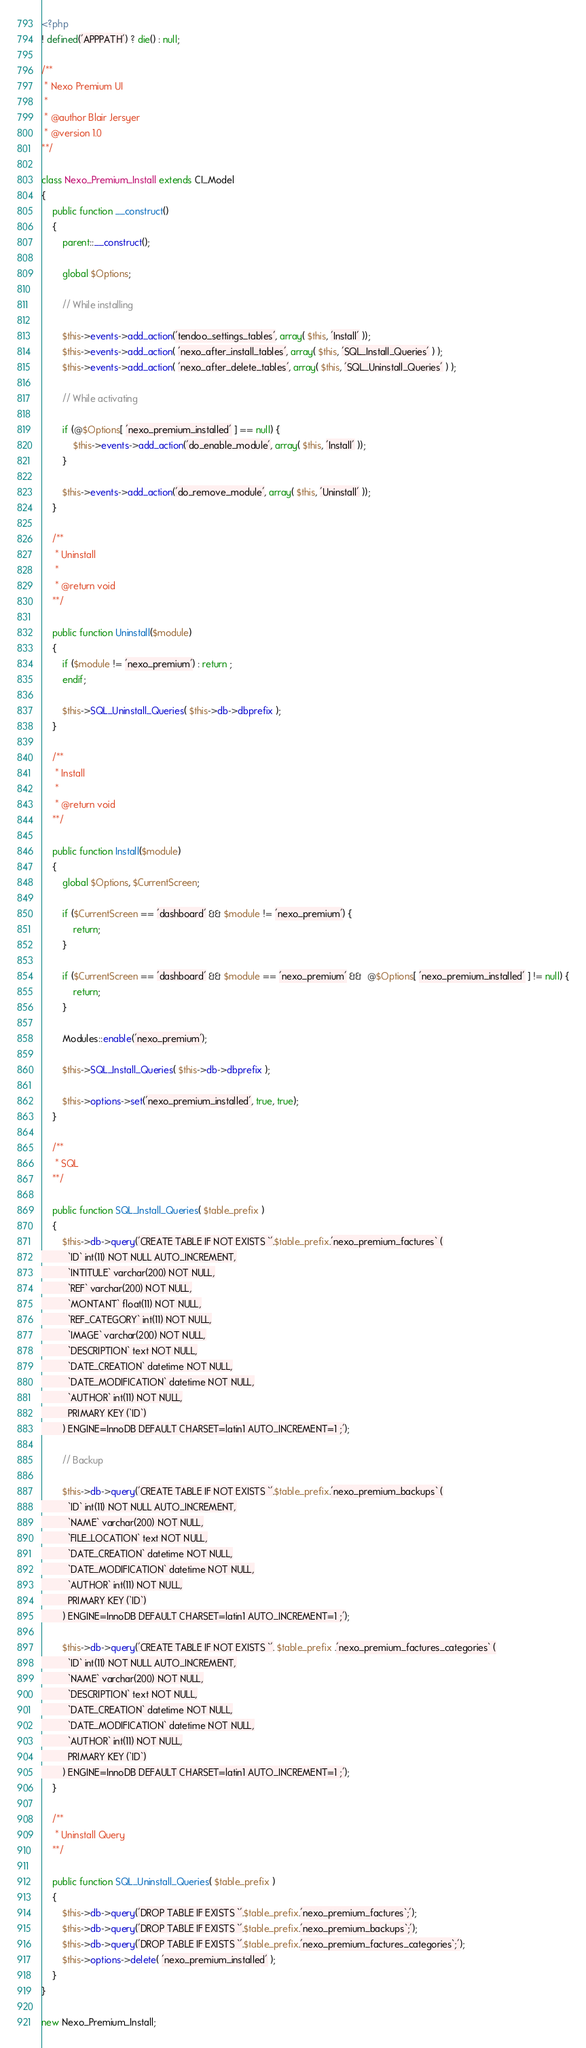Convert code to text. <code><loc_0><loc_0><loc_500><loc_500><_PHP_><?php
! defined('APPPATH') ? die() : null;

/**
 * Nexo Premium UI
 *
 * @author Blair Jersyer
 * @version 1.0
**/

class Nexo_Premium_Install extends CI_Model
{
    public function __construct()
    {
        parent::__construct();

        global $Options;

        // While installing

        $this->events->add_action('tendoo_settings_tables', array( $this, 'Install' ));
		$this->events->add_action( 'nexo_after_install_tables', array( $this, 'SQL_Install_Queries' ) );
		$this->events->add_action( 'nexo_after_delete_tables', array( $this, 'SQL_Uninstall_Queries' ) );

        // While activating

        if (@$Options[ 'nexo_premium_installed' ] == null) {
            $this->events->add_action('do_enable_module', array( $this, 'Install' ));
        }

        $this->events->add_action('do_remove_module', array( $this, 'Uninstall' ));
    }

    /**
     * Uninstall
     *
     * @return void
    **/

    public function Uninstall($module)
    {
        if ($module != 'nexo_premium') : return ;
        endif;

		$this->SQL_Uninstall_Queries( $this->db->dbprefix );
    }

    /**
     * Install
     *
     * @return void
    **/

    public function Install($module)
    {
        global $Options, $CurrentScreen;

        if ($CurrentScreen == 'dashboard' && $module != 'nexo_premium') {
            return;
        }

        if ($CurrentScreen == 'dashboard' && $module == 'nexo_premium' &&  @$Options[ 'nexo_premium_installed' ] != null) {
            return;
        }

        Modules::enable('nexo_premium');

        $this->SQL_Install_Queries( $this->db->dbprefix );

        $this->options->set('nexo_premium_installed', true, true);
    }

	/**
	 * SQL
	**/

	public function SQL_Install_Queries( $table_prefix )
	{
		$this->db->query('CREATE TABLE IF NOT EXISTS `'.$table_prefix.'nexo_premium_factures` (
		  `ID` int(11) NOT NULL AUTO_INCREMENT,
		  `INTITULE` varchar(200) NOT NULL,
		  `REF` varchar(200) NOT NULL,
		  `MONTANT` float(11) NOT NULL,
          `REF_CATEGORY` int(11) NOT NULL,
		  `IMAGE` varchar(200) NOT NULL,
		  `DESCRIPTION` text NOT NULL,
		  `DATE_CREATION` datetime NOT NULL,
		  `DATE_MODIFICATION` datetime NOT NULL,
		  `AUTHOR` int(11) NOT NULL,
		  PRIMARY KEY (`ID`)
		) ENGINE=InnoDB DEFAULT CHARSET=latin1 AUTO_INCREMENT=1 ;');

        // Backup

        $this->db->query('CREATE TABLE IF NOT EXISTS `'.$table_prefix.'nexo_premium_backups` (
		  `ID` int(11) NOT NULL AUTO_INCREMENT,
		  `NAME` varchar(200) NOT NULL,
		  `FILE_LOCATION` text NOT NULL,
		  `DATE_CREATION` datetime NOT NULL,
		  `DATE_MODIFICATION` datetime NOT NULL,
		  `AUTHOR` int(11) NOT NULL,
		  PRIMARY KEY (`ID`)
		) ENGINE=InnoDB DEFAULT CHARSET=latin1 AUTO_INCREMENT=1 ;');

        $this->db->query('CREATE TABLE IF NOT EXISTS `'. $table_prefix .'nexo_premium_factures_categories` (
          `ID` int(11) NOT NULL AUTO_INCREMENT,
          `NAME` varchar(200) NOT NULL,
          `DESCRIPTION` text NOT NULL,
          `DATE_CREATION` datetime NOT NULL,
          `DATE_MODIFICATION` datetime NOT NULL,
          `AUTHOR` int(11) NOT NULL,
          PRIMARY KEY (`ID`)
        ) ENGINE=InnoDB DEFAULT CHARSET=latin1 AUTO_INCREMENT=1 ;');
	}

	/**
	 * Uninstall Query
	**/

	public function SQL_Uninstall_Queries( $table_prefix )
	{
		$this->db->query('DROP TABLE IF EXISTS `'.$table_prefix.'nexo_premium_factures`;');
		$this->db->query('DROP TABLE IF EXISTS `'.$table_prefix.'nexo_premium_backups`;');
        $this->db->query('DROP TABLE IF EXISTS `'.$table_prefix.'nexo_premium_factures_categories`;');
        $this->options->delete( 'nexo_premium_installed' );
	}
}

new Nexo_Premium_Install;
</code> 